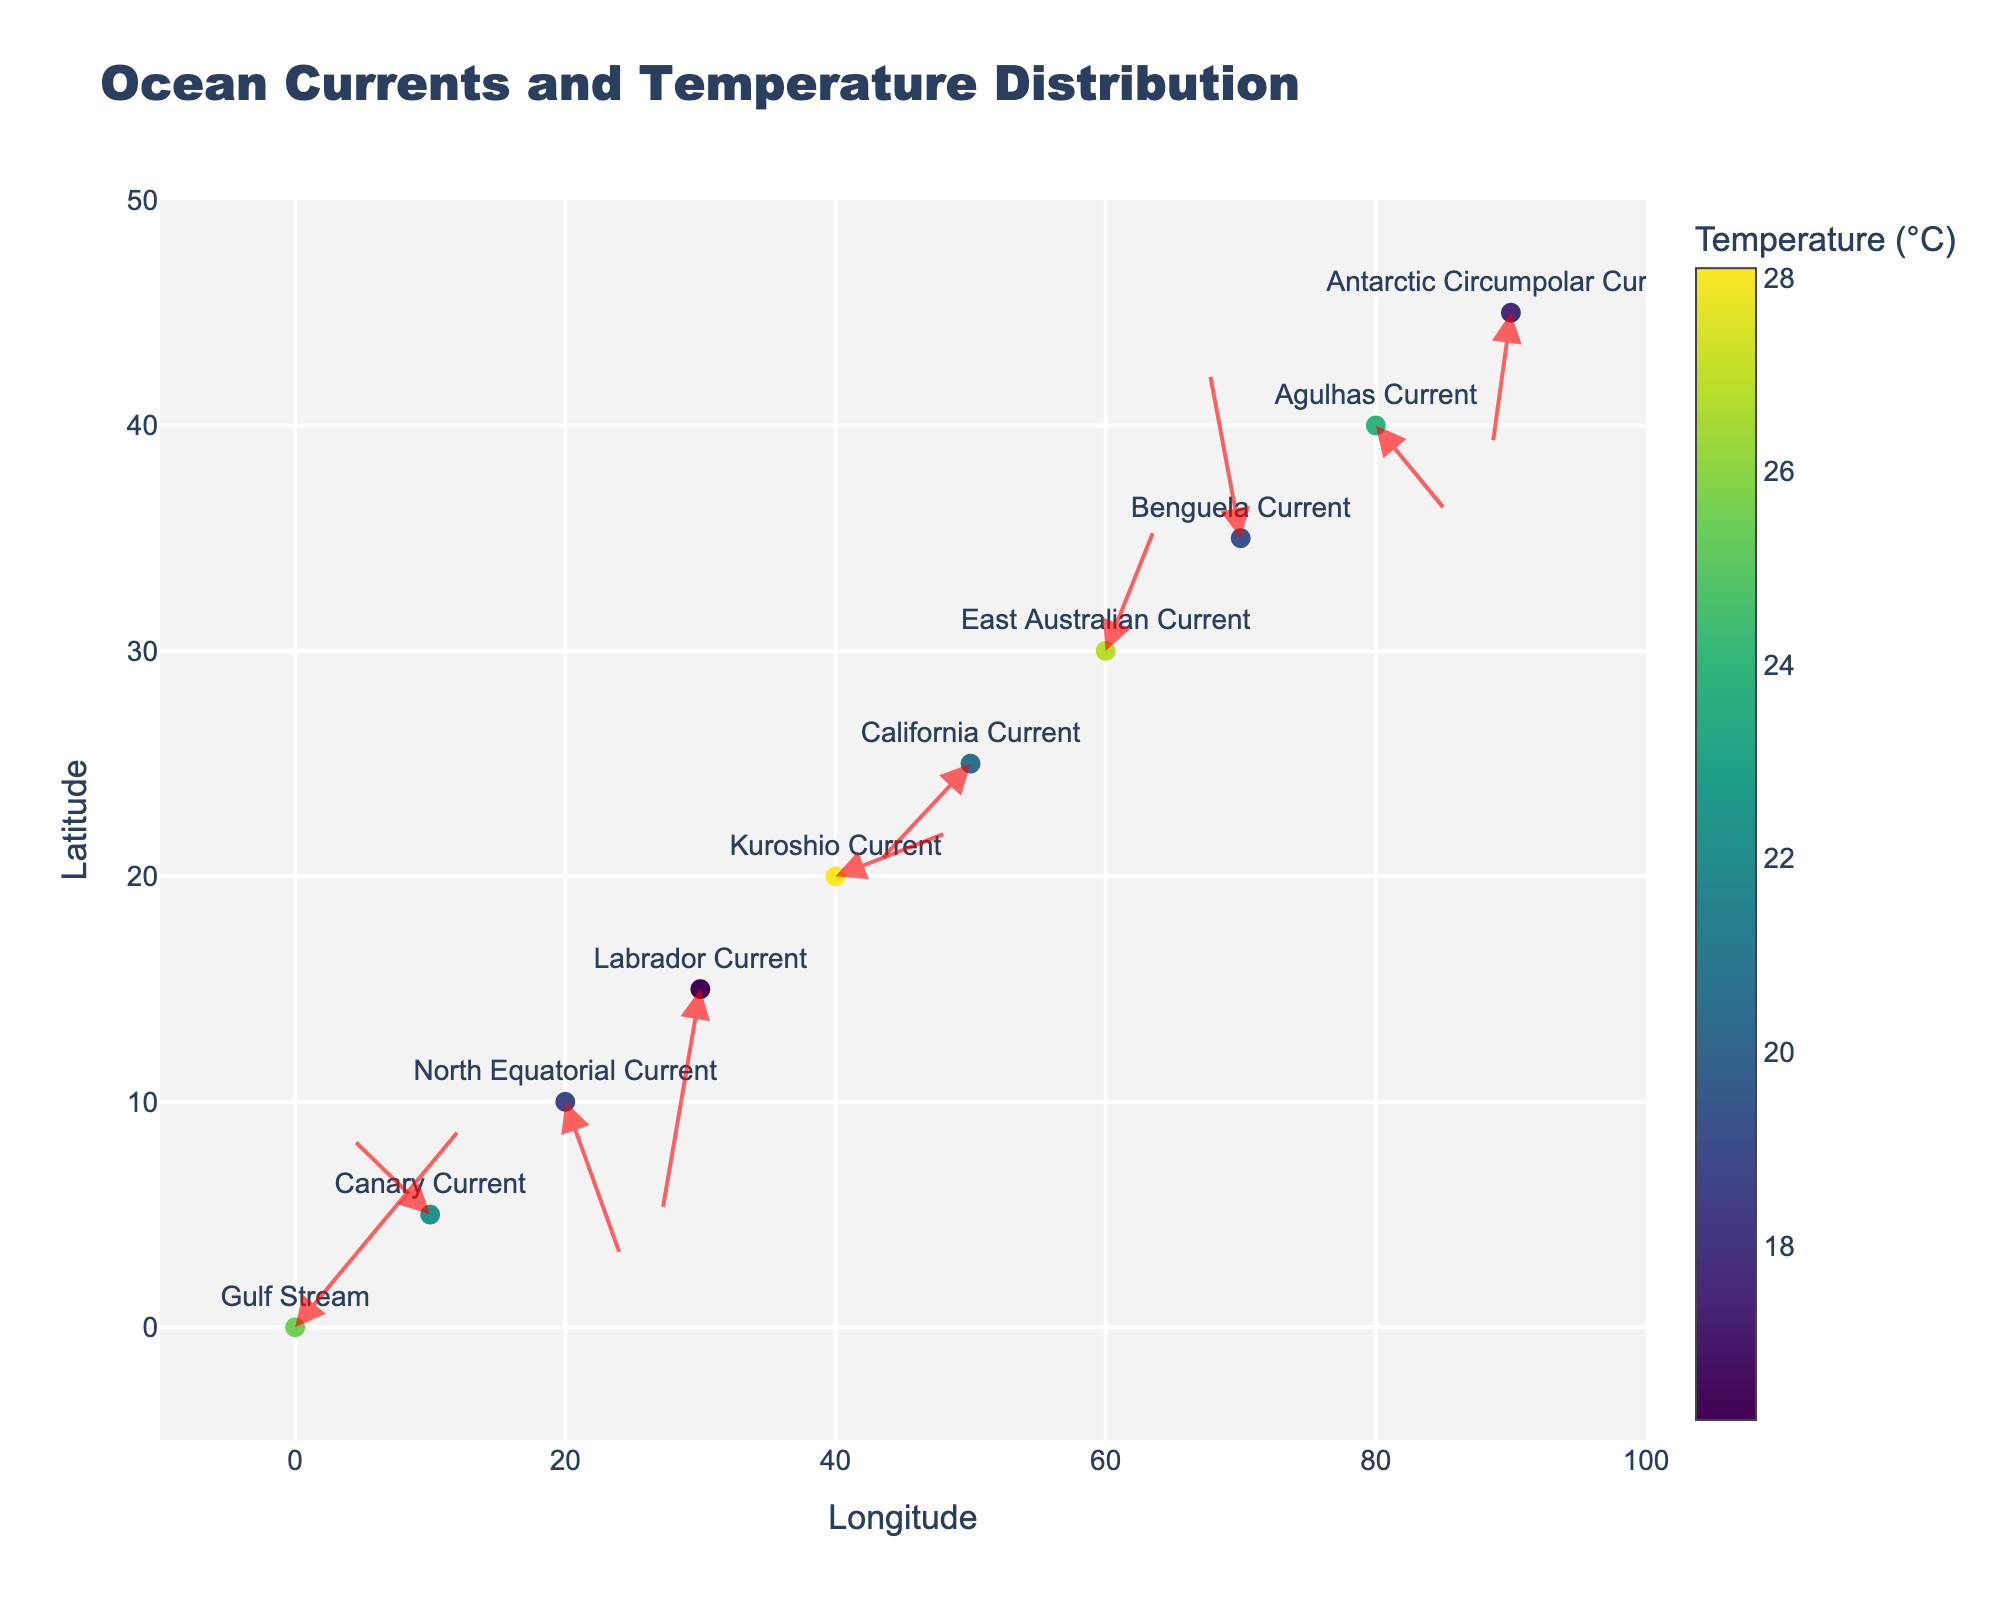What is the overall title of the figure? The overall title is prominently displayed at the top of the figure, stating the main topic it represents. By reading the text at the top, you can determine the exact title.
Answer: Ocean Currents and Temperature Distribution Which ocean current has the highest temperature? By examining the color scale and the markers representing different ocean currents, you can identify the one with the highest temperature. The color associated with the highest temperature on the color scale will be on this marker.
Answer: Kuroshio Current What is the longitude and latitude of the East Australian Current? Find the text labeled "East Australian Current" on the figure. Next to this label are the coordinates, which you can read off the respective axes.
Answer: 60, 30 Which ocean currents are moving southwards? Look for currents with arrows pointing downwards (negative y-direction). Arrows pointing downwards indicate a southward movement.
Answer: North Equatorial Current, Labrador Current, Antarctic Circumpolar Current Compare the temperature of the Gulf Stream and the Labrador Current. Which one is warmer and by how much? Identify the markers for the Gulf Stream and Labrador Current. Use the color scale and numerical temperature values to find their respective temperatures. Subtract the Cooler current's temperature from the warmer one.
Answer: The Gulf Stream is warmer by 9.3°C What is the average temperature of all the ocean currents represented? Add up all the temperatures given for each ocean current and divide by the number of currents (10).
Answer: (25.5 + 22.3 + 18.7 + 16.2 + 28.1 + 20.5 + 26.8 + 19.3 + 23.9 + 17.6) / 10 = 21.89°C Which current has the longest vector, indicating the strongest current flow? Compare the magnitudes of the vectors (hypotenuses). The formula is √(u² + v²). Calculate for each current and identify the maximum.
Answer: Gulf Stream Identify currents with a predominantly eastward direction. How many are there? Look for currents with positive x-values in the velocity components (u). Eastward direction corresponds to positive u-values. Count those currents.
Answer: 4 What does the arrow size represent in the figure? The arrows indicate the direction and speed of ocean currents. Larger arrows represent stronger currents, indicated by their length on the figure.
Answer: Direction and speed of ocean currents Which current is situated at the highest latitude? Examine the y-axis values to find the highest value and look at the corresponding ocean current label.
Answer: Antarctic Circumpolar Current 